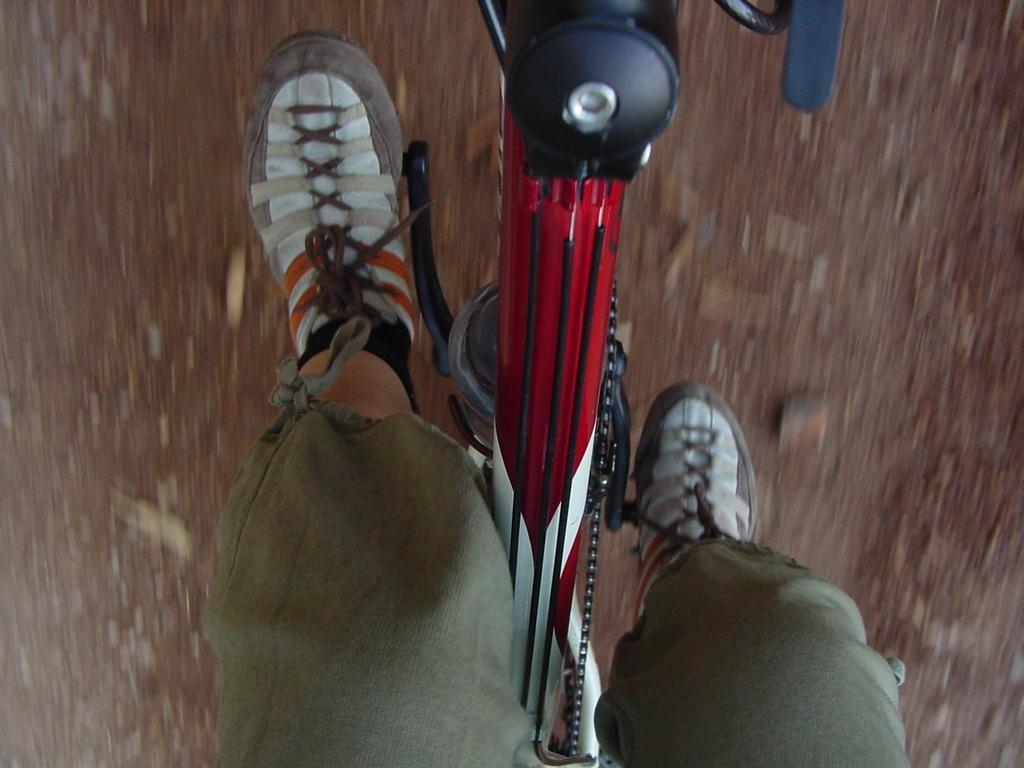How would you summarize this image in a sentence or two? There is a person riding a cycle. In the background it is blurred. 